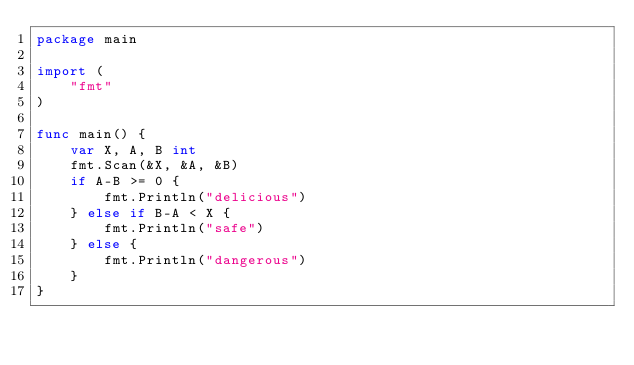<code> <loc_0><loc_0><loc_500><loc_500><_Go_>package main

import (
	"fmt"
)

func main() {
	var X, A, B int
	fmt.Scan(&X, &A, &B)
	if A-B >= 0 {
		fmt.Println("delicious")
	} else if B-A < X {
		fmt.Println("safe")
	} else {
		fmt.Println("dangerous")
	}
}
</code> 